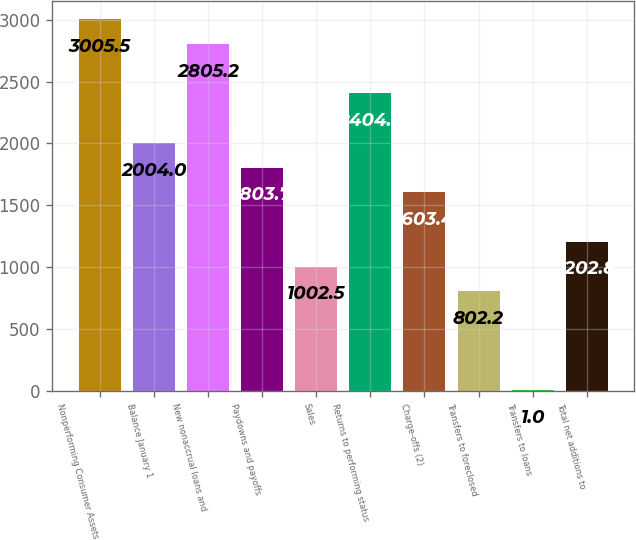<chart> <loc_0><loc_0><loc_500><loc_500><bar_chart><fcel>Nonperforming Consumer Assets<fcel>Balance January 1<fcel>New nonaccrual loans and<fcel>Paydowns and payoffs<fcel>Sales<fcel>Returns to performing status<fcel>Charge-offs (2)<fcel>Transfers to foreclosed<fcel>Transfers to loans<fcel>Total net additions to<nl><fcel>3005.5<fcel>2004<fcel>2805.2<fcel>1803.7<fcel>1002.5<fcel>2404.6<fcel>1603.4<fcel>802.2<fcel>1<fcel>1202.8<nl></chart> 